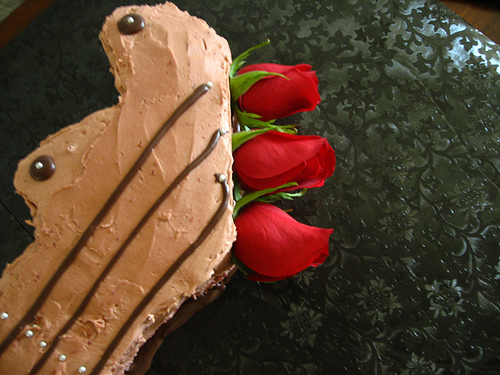<image>
Is the rose on the table? Yes. Looking at the image, I can see the rose is positioned on top of the table, with the table providing support. 